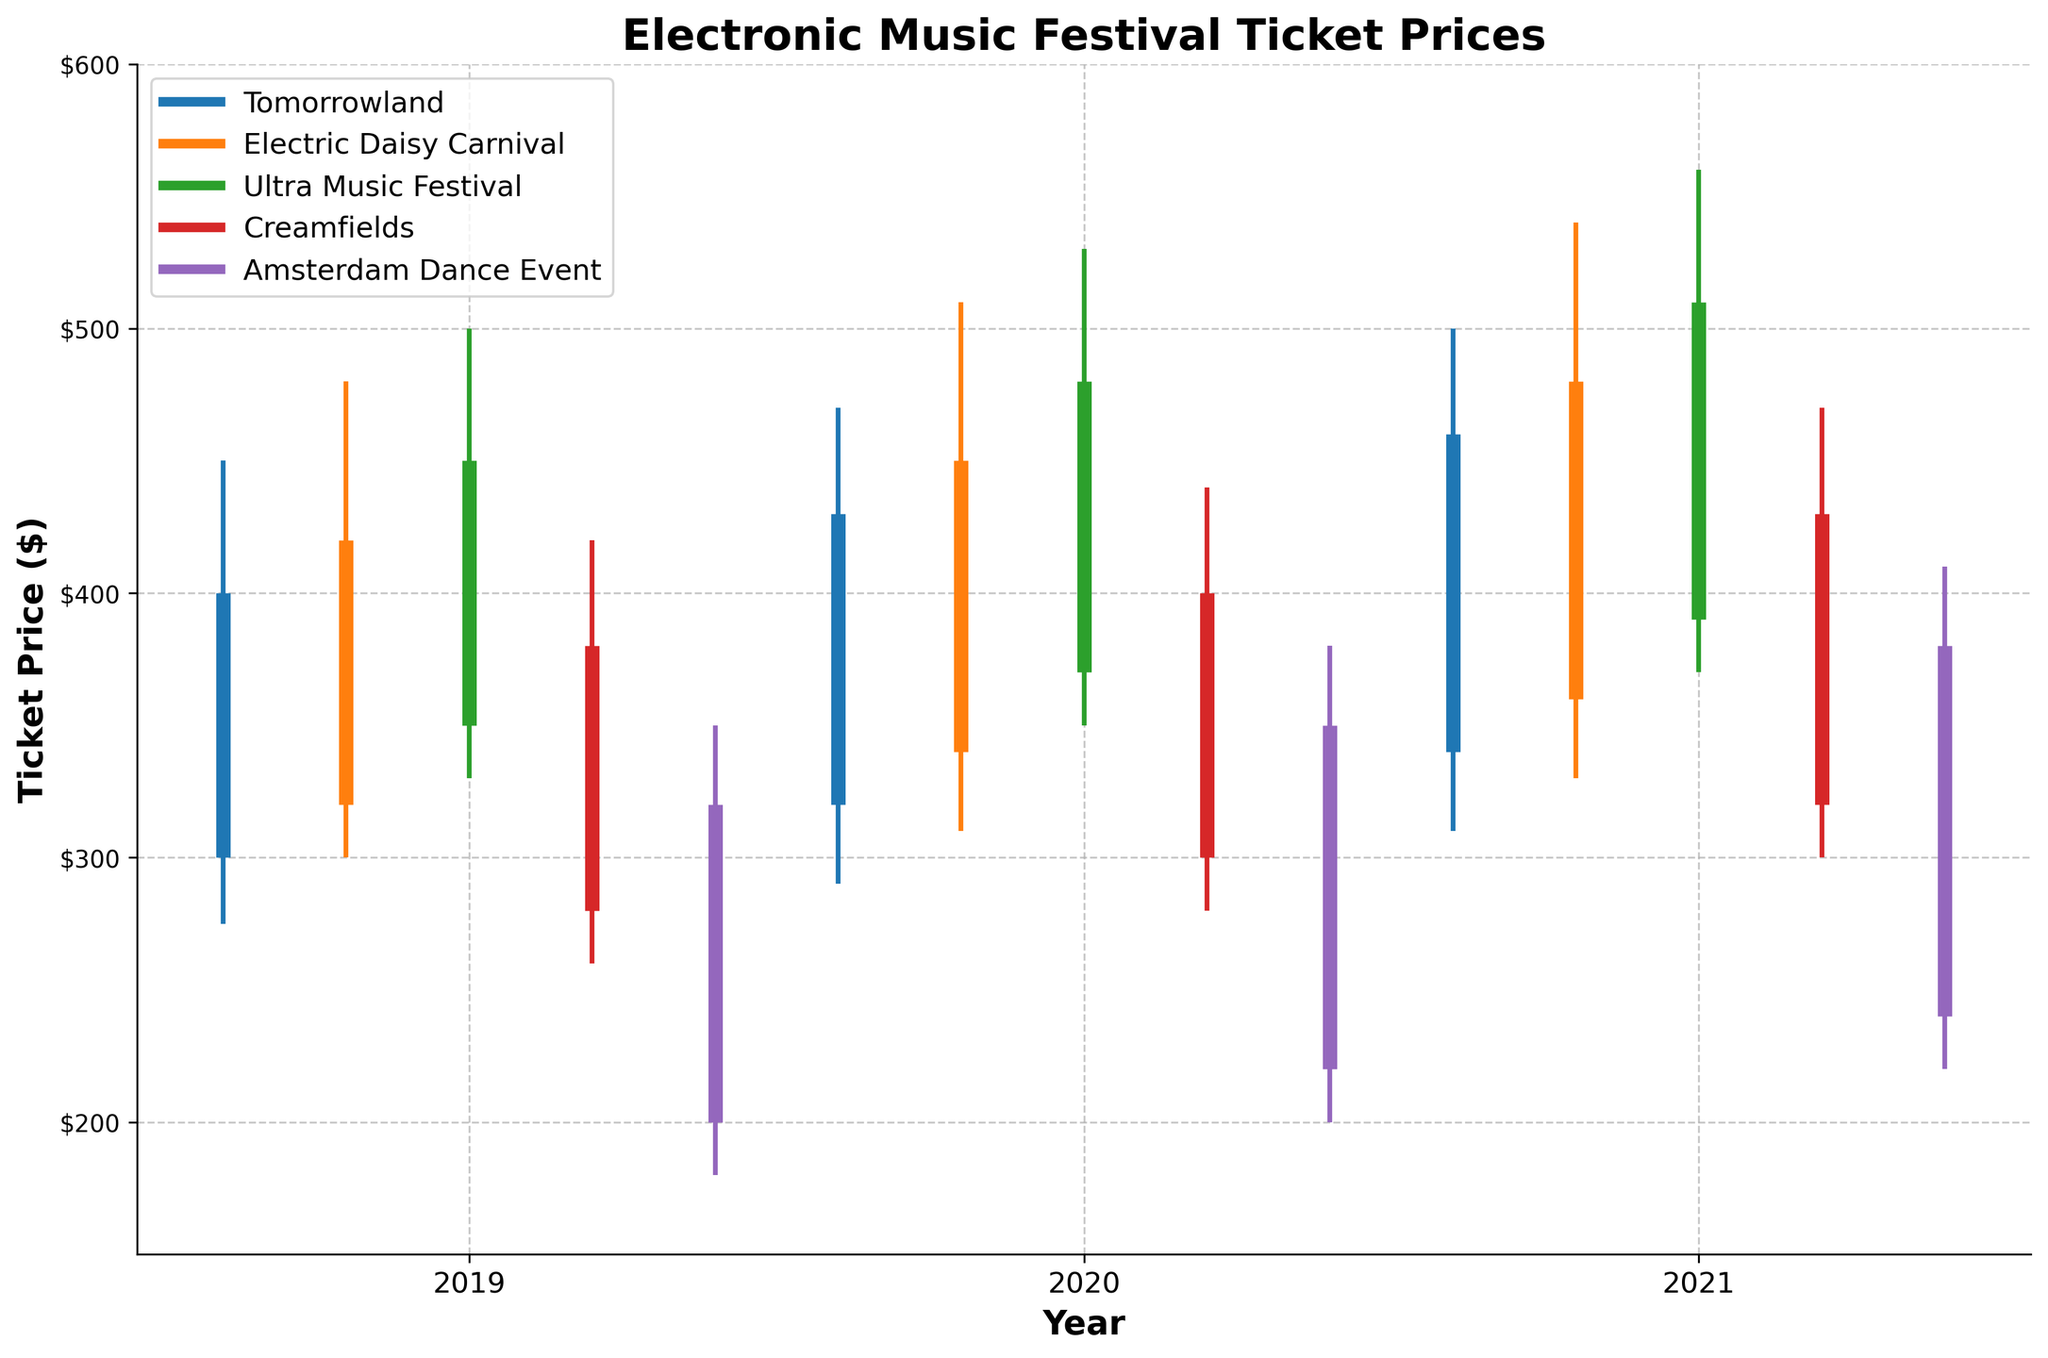What's the title of the chart? The title is usually placed at the top of the chart and is intended to give a quick summary of what the chart represents. The title here reads "Electronic Music Festival Ticket Prices".
Answer: Electronic Music Festival Ticket Prices What are the label names for the X and Y axes? Axes labels are usually found along the respective axes. In this chart, the X-axis is labeled "Year" and the Y-axis is labeled "Ticket Price ($)".
Answer: Year and Ticket Price ($) Which festival had the highest ticket price in 2021? To find the highest ticket price in 2021, look for the highest point on the chart corresponding to 2021. The "Ultra Music Festival" reached $560, which is the highest value for that year.
Answer: Ultra Music Festival What were the ticket prices for Tomorrowland in 2019? Look at the OHLC line for Tomorrowland in 2019 to identify the Open, High, Low, and Close prices. They are: Open = $300, High = $450, Low = $275, Close = $400.
Answer: Open: $300, High: $450, Low: $275, Close: $400 How did the ticket prices for Creamfields change from 2019 to 2021? Compositional questions require noting the Open, High, Low, and Close prices across multiple years. In 2019, Creamfields had: Open = $280, Close = $380. In 2021, they had: Open = $320, Close = $430. Changes: Open $\Delta = 320 - 280 = 40$, Close $\Delta = 430 - 380 = 50$.
Answer: Open: increased by $40, Close: increased by $50 Which festival had the most stable (smallest range) ticket price in 2020? The stability of a ticket price can be inferred from the range (High - Low) for each festival in that year. The ranges are calculated as: Tomorrowland = $180, Electric Daisy Carnival = $200, Ultra Music Festival = $180, Creamfields = $160, Amsterdam Dance Event = $180. Creamfields had the smallest range of $160.
Answer: Creamfields Which festival showed the greatest increase in closing ticket prices from 2019 to 2021? Calculate the difference in closing prices from 2019 to 2021 for each festival. Tomorrowland: $60, Electric Daisy Carnival: $60, Ultra Music Festival: $60, Creamfields: $50, Amsterdam Dance Event: $60. They are tied at $60 increase.
Answer: Tomorrowland, Electric Daisy Carnival, Ultra Music Festival, and Amsterdam Dance Event What was the average ticket price for Tomorrowland in 2020? The average price is calculated from the OHLC values. For Tomorrowland in 2020: ($320 + $470 + $290 + $430)/4. Sum = $1510, Average = $1510/4 = $377.50
Answer: $377.50 Did the ticket prices for Amsterdam Dance Event always increase from the open to close from 2019 to 2021? Check the open and close values for each year. In 2019: Open = $200, Close = $320 (increase). In 2020: Open = $220, Close = $350 (increase). In 2021: Open = $240, Close = $380 (increase). All years show an increase from open to close.
Answer: Yes 